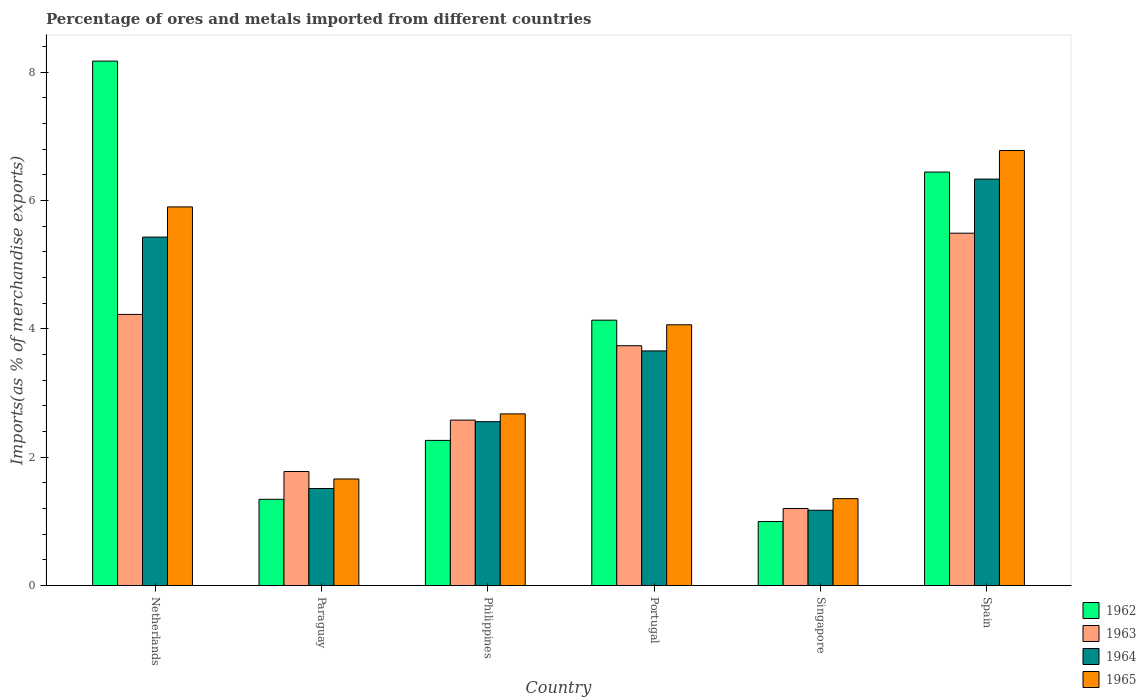How many groups of bars are there?
Your answer should be very brief. 6. How many bars are there on the 1st tick from the left?
Your answer should be compact. 4. What is the label of the 2nd group of bars from the left?
Keep it short and to the point. Paraguay. In how many cases, is the number of bars for a given country not equal to the number of legend labels?
Your answer should be very brief. 0. What is the percentage of imports to different countries in 1964 in Netherlands?
Ensure brevity in your answer.  5.43. Across all countries, what is the maximum percentage of imports to different countries in 1964?
Provide a succinct answer. 6.33. Across all countries, what is the minimum percentage of imports to different countries in 1965?
Ensure brevity in your answer.  1.35. In which country was the percentage of imports to different countries in 1964 minimum?
Your answer should be very brief. Singapore. What is the total percentage of imports to different countries in 1964 in the graph?
Keep it short and to the point. 20.66. What is the difference between the percentage of imports to different countries in 1964 in Netherlands and that in Philippines?
Give a very brief answer. 2.88. What is the difference between the percentage of imports to different countries in 1964 in Paraguay and the percentage of imports to different countries in 1965 in Singapore?
Make the answer very short. 0.16. What is the average percentage of imports to different countries in 1962 per country?
Provide a short and direct response. 3.89. What is the difference between the percentage of imports to different countries of/in 1963 and percentage of imports to different countries of/in 1965 in Spain?
Your answer should be very brief. -1.29. In how many countries, is the percentage of imports to different countries in 1963 greater than 2 %?
Offer a terse response. 4. What is the ratio of the percentage of imports to different countries in 1962 in Singapore to that in Spain?
Offer a terse response. 0.15. What is the difference between the highest and the second highest percentage of imports to different countries in 1965?
Ensure brevity in your answer.  -1.84. What is the difference between the highest and the lowest percentage of imports to different countries in 1965?
Keep it short and to the point. 5.42. Is the sum of the percentage of imports to different countries in 1964 in Netherlands and Spain greater than the maximum percentage of imports to different countries in 1962 across all countries?
Your answer should be compact. Yes. Is it the case that in every country, the sum of the percentage of imports to different countries in 1962 and percentage of imports to different countries in 1963 is greater than the sum of percentage of imports to different countries in 1965 and percentage of imports to different countries in 1964?
Your response must be concise. No. What does the 4th bar from the left in Philippines represents?
Provide a short and direct response. 1965. What does the 4th bar from the right in Singapore represents?
Give a very brief answer. 1962. Is it the case that in every country, the sum of the percentage of imports to different countries in 1964 and percentage of imports to different countries in 1962 is greater than the percentage of imports to different countries in 1965?
Make the answer very short. Yes. Are all the bars in the graph horizontal?
Your response must be concise. No. What is the difference between two consecutive major ticks on the Y-axis?
Your response must be concise. 2. Does the graph contain any zero values?
Give a very brief answer. No. Does the graph contain grids?
Ensure brevity in your answer.  No. How many legend labels are there?
Your answer should be very brief. 4. What is the title of the graph?
Give a very brief answer. Percentage of ores and metals imported from different countries. What is the label or title of the X-axis?
Provide a succinct answer. Country. What is the label or title of the Y-axis?
Your answer should be very brief. Imports(as % of merchandise exports). What is the Imports(as % of merchandise exports) of 1962 in Netherlands?
Give a very brief answer. 8.17. What is the Imports(as % of merchandise exports) in 1963 in Netherlands?
Give a very brief answer. 4.22. What is the Imports(as % of merchandise exports) of 1964 in Netherlands?
Provide a succinct answer. 5.43. What is the Imports(as % of merchandise exports) of 1965 in Netherlands?
Make the answer very short. 5.9. What is the Imports(as % of merchandise exports) in 1962 in Paraguay?
Offer a very short reply. 1.34. What is the Imports(as % of merchandise exports) of 1963 in Paraguay?
Ensure brevity in your answer.  1.78. What is the Imports(as % of merchandise exports) of 1964 in Paraguay?
Provide a short and direct response. 1.51. What is the Imports(as % of merchandise exports) of 1965 in Paraguay?
Provide a short and direct response. 1.66. What is the Imports(as % of merchandise exports) in 1962 in Philippines?
Your response must be concise. 2.26. What is the Imports(as % of merchandise exports) of 1963 in Philippines?
Offer a terse response. 2.58. What is the Imports(as % of merchandise exports) in 1964 in Philippines?
Provide a short and direct response. 2.55. What is the Imports(as % of merchandise exports) of 1965 in Philippines?
Keep it short and to the point. 2.67. What is the Imports(as % of merchandise exports) in 1962 in Portugal?
Make the answer very short. 4.13. What is the Imports(as % of merchandise exports) of 1963 in Portugal?
Offer a very short reply. 3.74. What is the Imports(as % of merchandise exports) in 1964 in Portugal?
Your answer should be very brief. 3.66. What is the Imports(as % of merchandise exports) in 1965 in Portugal?
Provide a short and direct response. 4.06. What is the Imports(as % of merchandise exports) of 1962 in Singapore?
Offer a terse response. 1. What is the Imports(as % of merchandise exports) in 1963 in Singapore?
Ensure brevity in your answer.  1.2. What is the Imports(as % of merchandise exports) of 1964 in Singapore?
Provide a short and direct response. 1.17. What is the Imports(as % of merchandise exports) of 1965 in Singapore?
Your answer should be very brief. 1.35. What is the Imports(as % of merchandise exports) of 1962 in Spain?
Offer a very short reply. 6.44. What is the Imports(as % of merchandise exports) in 1963 in Spain?
Your answer should be very brief. 5.49. What is the Imports(as % of merchandise exports) of 1964 in Spain?
Your answer should be very brief. 6.33. What is the Imports(as % of merchandise exports) in 1965 in Spain?
Keep it short and to the point. 6.78. Across all countries, what is the maximum Imports(as % of merchandise exports) in 1962?
Give a very brief answer. 8.17. Across all countries, what is the maximum Imports(as % of merchandise exports) in 1963?
Give a very brief answer. 5.49. Across all countries, what is the maximum Imports(as % of merchandise exports) of 1964?
Keep it short and to the point. 6.33. Across all countries, what is the maximum Imports(as % of merchandise exports) of 1965?
Your response must be concise. 6.78. Across all countries, what is the minimum Imports(as % of merchandise exports) of 1962?
Provide a short and direct response. 1. Across all countries, what is the minimum Imports(as % of merchandise exports) of 1963?
Provide a short and direct response. 1.2. Across all countries, what is the minimum Imports(as % of merchandise exports) of 1964?
Offer a terse response. 1.17. Across all countries, what is the minimum Imports(as % of merchandise exports) in 1965?
Provide a short and direct response. 1.35. What is the total Imports(as % of merchandise exports) in 1962 in the graph?
Provide a short and direct response. 23.35. What is the total Imports(as % of merchandise exports) of 1963 in the graph?
Provide a short and direct response. 19.01. What is the total Imports(as % of merchandise exports) of 1964 in the graph?
Keep it short and to the point. 20.66. What is the total Imports(as % of merchandise exports) of 1965 in the graph?
Offer a terse response. 22.43. What is the difference between the Imports(as % of merchandise exports) of 1962 in Netherlands and that in Paraguay?
Your answer should be compact. 6.83. What is the difference between the Imports(as % of merchandise exports) in 1963 in Netherlands and that in Paraguay?
Offer a terse response. 2.45. What is the difference between the Imports(as % of merchandise exports) of 1964 in Netherlands and that in Paraguay?
Ensure brevity in your answer.  3.92. What is the difference between the Imports(as % of merchandise exports) in 1965 in Netherlands and that in Paraguay?
Ensure brevity in your answer.  4.24. What is the difference between the Imports(as % of merchandise exports) of 1962 in Netherlands and that in Philippines?
Offer a very short reply. 5.91. What is the difference between the Imports(as % of merchandise exports) of 1963 in Netherlands and that in Philippines?
Offer a very short reply. 1.65. What is the difference between the Imports(as % of merchandise exports) in 1964 in Netherlands and that in Philippines?
Offer a terse response. 2.88. What is the difference between the Imports(as % of merchandise exports) of 1965 in Netherlands and that in Philippines?
Offer a very short reply. 3.22. What is the difference between the Imports(as % of merchandise exports) in 1962 in Netherlands and that in Portugal?
Make the answer very short. 4.04. What is the difference between the Imports(as % of merchandise exports) in 1963 in Netherlands and that in Portugal?
Provide a short and direct response. 0.49. What is the difference between the Imports(as % of merchandise exports) of 1964 in Netherlands and that in Portugal?
Keep it short and to the point. 1.77. What is the difference between the Imports(as % of merchandise exports) in 1965 in Netherlands and that in Portugal?
Keep it short and to the point. 1.84. What is the difference between the Imports(as % of merchandise exports) in 1962 in Netherlands and that in Singapore?
Ensure brevity in your answer.  7.17. What is the difference between the Imports(as % of merchandise exports) of 1963 in Netherlands and that in Singapore?
Provide a short and direct response. 3.02. What is the difference between the Imports(as % of merchandise exports) of 1964 in Netherlands and that in Singapore?
Offer a very short reply. 4.26. What is the difference between the Imports(as % of merchandise exports) in 1965 in Netherlands and that in Singapore?
Give a very brief answer. 4.55. What is the difference between the Imports(as % of merchandise exports) in 1962 in Netherlands and that in Spain?
Your response must be concise. 1.73. What is the difference between the Imports(as % of merchandise exports) of 1963 in Netherlands and that in Spain?
Offer a terse response. -1.27. What is the difference between the Imports(as % of merchandise exports) of 1964 in Netherlands and that in Spain?
Your response must be concise. -0.9. What is the difference between the Imports(as % of merchandise exports) of 1965 in Netherlands and that in Spain?
Your answer should be compact. -0.88. What is the difference between the Imports(as % of merchandise exports) of 1962 in Paraguay and that in Philippines?
Provide a short and direct response. -0.92. What is the difference between the Imports(as % of merchandise exports) of 1963 in Paraguay and that in Philippines?
Ensure brevity in your answer.  -0.8. What is the difference between the Imports(as % of merchandise exports) of 1964 in Paraguay and that in Philippines?
Your answer should be compact. -1.04. What is the difference between the Imports(as % of merchandise exports) in 1965 in Paraguay and that in Philippines?
Ensure brevity in your answer.  -1.01. What is the difference between the Imports(as % of merchandise exports) in 1962 in Paraguay and that in Portugal?
Keep it short and to the point. -2.79. What is the difference between the Imports(as % of merchandise exports) of 1963 in Paraguay and that in Portugal?
Give a very brief answer. -1.96. What is the difference between the Imports(as % of merchandise exports) of 1964 in Paraguay and that in Portugal?
Your answer should be very brief. -2.14. What is the difference between the Imports(as % of merchandise exports) of 1965 in Paraguay and that in Portugal?
Provide a short and direct response. -2.4. What is the difference between the Imports(as % of merchandise exports) of 1962 in Paraguay and that in Singapore?
Your response must be concise. 0.35. What is the difference between the Imports(as % of merchandise exports) of 1963 in Paraguay and that in Singapore?
Offer a terse response. 0.58. What is the difference between the Imports(as % of merchandise exports) in 1964 in Paraguay and that in Singapore?
Provide a succinct answer. 0.34. What is the difference between the Imports(as % of merchandise exports) in 1965 in Paraguay and that in Singapore?
Provide a short and direct response. 0.31. What is the difference between the Imports(as % of merchandise exports) of 1962 in Paraguay and that in Spain?
Keep it short and to the point. -5.1. What is the difference between the Imports(as % of merchandise exports) of 1963 in Paraguay and that in Spain?
Offer a terse response. -3.71. What is the difference between the Imports(as % of merchandise exports) in 1964 in Paraguay and that in Spain?
Your answer should be compact. -4.82. What is the difference between the Imports(as % of merchandise exports) of 1965 in Paraguay and that in Spain?
Give a very brief answer. -5.12. What is the difference between the Imports(as % of merchandise exports) of 1962 in Philippines and that in Portugal?
Give a very brief answer. -1.87. What is the difference between the Imports(as % of merchandise exports) in 1963 in Philippines and that in Portugal?
Offer a very short reply. -1.16. What is the difference between the Imports(as % of merchandise exports) of 1964 in Philippines and that in Portugal?
Offer a terse response. -1.1. What is the difference between the Imports(as % of merchandise exports) of 1965 in Philippines and that in Portugal?
Your answer should be compact. -1.39. What is the difference between the Imports(as % of merchandise exports) of 1962 in Philippines and that in Singapore?
Keep it short and to the point. 1.26. What is the difference between the Imports(as % of merchandise exports) in 1963 in Philippines and that in Singapore?
Your answer should be compact. 1.38. What is the difference between the Imports(as % of merchandise exports) in 1964 in Philippines and that in Singapore?
Your response must be concise. 1.38. What is the difference between the Imports(as % of merchandise exports) in 1965 in Philippines and that in Singapore?
Offer a terse response. 1.32. What is the difference between the Imports(as % of merchandise exports) of 1962 in Philippines and that in Spain?
Offer a terse response. -4.18. What is the difference between the Imports(as % of merchandise exports) of 1963 in Philippines and that in Spain?
Offer a very short reply. -2.91. What is the difference between the Imports(as % of merchandise exports) of 1964 in Philippines and that in Spain?
Offer a terse response. -3.78. What is the difference between the Imports(as % of merchandise exports) in 1965 in Philippines and that in Spain?
Ensure brevity in your answer.  -4.1. What is the difference between the Imports(as % of merchandise exports) in 1962 in Portugal and that in Singapore?
Your answer should be very brief. 3.14. What is the difference between the Imports(as % of merchandise exports) in 1963 in Portugal and that in Singapore?
Provide a succinct answer. 2.54. What is the difference between the Imports(as % of merchandise exports) of 1964 in Portugal and that in Singapore?
Ensure brevity in your answer.  2.48. What is the difference between the Imports(as % of merchandise exports) in 1965 in Portugal and that in Singapore?
Offer a very short reply. 2.71. What is the difference between the Imports(as % of merchandise exports) in 1962 in Portugal and that in Spain?
Your answer should be compact. -2.31. What is the difference between the Imports(as % of merchandise exports) in 1963 in Portugal and that in Spain?
Your answer should be compact. -1.75. What is the difference between the Imports(as % of merchandise exports) in 1964 in Portugal and that in Spain?
Your answer should be very brief. -2.68. What is the difference between the Imports(as % of merchandise exports) of 1965 in Portugal and that in Spain?
Provide a short and direct response. -2.72. What is the difference between the Imports(as % of merchandise exports) in 1962 in Singapore and that in Spain?
Your answer should be very brief. -5.45. What is the difference between the Imports(as % of merchandise exports) of 1963 in Singapore and that in Spain?
Give a very brief answer. -4.29. What is the difference between the Imports(as % of merchandise exports) of 1964 in Singapore and that in Spain?
Provide a short and direct response. -5.16. What is the difference between the Imports(as % of merchandise exports) of 1965 in Singapore and that in Spain?
Your answer should be compact. -5.42. What is the difference between the Imports(as % of merchandise exports) in 1962 in Netherlands and the Imports(as % of merchandise exports) in 1963 in Paraguay?
Offer a very short reply. 6.39. What is the difference between the Imports(as % of merchandise exports) of 1962 in Netherlands and the Imports(as % of merchandise exports) of 1964 in Paraguay?
Offer a terse response. 6.66. What is the difference between the Imports(as % of merchandise exports) in 1962 in Netherlands and the Imports(as % of merchandise exports) in 1965 in Paraguay?
Your answer should be compact. 6.51. What is the difference between the Imports(as % of merchandise exports) of 1963 in Netherlands and the Imports(as % of merchandise exports) of 1964 in Paraguay?
Offer a terse response. 2.71. What is the difference between the Imports(as % of merchandise exports) in 1963 in Netherlands and the Imports(as % of merchandise exports) in 1965 in Paraguay?
Provide a short and direct response. 2.56. What is the difference between the Imports(as % of merchandise exports) in 1964 in Netherlands and the Imports(as % of merchandise exports) in 1965 in Paraguay?
Offer a terse response. 3.77. What is the difference between the Imports(as % of merchandise exports) of 1962 in Netherlands and the Imports(as % of merchandise exports) of 1963 in Philippines?
Make the answer very short. 5.59. What is the difference between the Imports(as % of merchandise exports) in 1962 in Netherlands and the Imports(as % of merchandise exports) in 1964 in Philippines?
Your response must be concise. 5.62. What is the difference between the Imports(as % of merchandise exports) in 1962 in Netherlands and the Imports(as % of merchandise exports) in 1965 in Philippines?
Your response must be concise. 5.5. What is the difference between the Imports(as % of merchandise exports) of 1963 in Netherlands and the Imports(as % of merchandise exports) of 1964 in Philippines?
Your response must be concise. 1.67. What is the difference between the Imports(as % of merchandise exports) in 1963 in Netherlands and the Imports(as % of merchandise exports) in 1965 in Philippines?
Your response must be concise. 1.55. What is the difference between the Imports(as % of merchandise exports) in 1964 in Netherlands and the Imports(as % of merchandise exports) in 1965 in Philippines?
Your answer should be very brief. 2.75. What is the difference between the Imports(as % of merchandise exports) of 1962 in Netherlands and the Imports(as % of merchandise exports) of 1963 in Portugal?
Keep it short and to the point. 4.43. What is the difference between the Imports(as % of merchandise exports) in 1962 in Netherlands and the Imports(as % of merchandise exports) in 1964 in Portugal?
Provide a short and direct response. 4.51. What is the difference between the Imports(as % of merchandise exports) of 1962 in Netherlands and the Imports(as % of merchandise exports) of 1965 in Portugal?
Your answer should be compact. 4.11. What is the difference between the Imports(as % of merchandise exports) of 1963 in Netherlands and the Imports(as % of merchandise exports) of 1964 in Portugal?
Provide a succinct answer. 0.57. What is the difference between the Imports(as % of merchandise exports) in 1963 in Netherlands and the Imports(as % of merchandise exports) in 1965 in Portugal?
Your answer should be very brief. 0.16. What is the difference between the Imports(as % of merchandise exports) in 1964 in Netherlands and the Imports(as % of merchandise exports) in 1965 in Portugal?
Provide a succinct answer. 1.37. What is the difference between the Imports(as % of merchandise exports) of 1962 in Netherlands and the Imports(as % of merchandise exports) of 1963 in Singapore?
Provide a succinct answer. 6.97. What is the difference between the Imports(as % of merchandise exports) in 1962 in Netherlands and the Imports(as % of merchandise exports) in 1964 in Singapore?
Offer a very short reply. 7. What is the difference between the Imports(as % of merchandise exports) in 1962 in Netherlands and the Imports(as % of merchandise exports) in 1965 in Singapore?
Make the answer very short. 6.82. What is the difference between the Imports(as % of merchandise exports) of 1963 in Netherlands and the Imports(as % of merchandise exports) of 1964 in Singapore?
Make the answer very short. 3.05. What is the difference between the Imports(as % of merchandise exports) in 1963 in Netherlands and the Imports(as % of merchandise exports) in 1965 in Singapore?
Keep it short and to the point. 2.87. What is the difference between the Imports(as % of merchandise exports) in 1964 in Netherlands and the Imports(as % of merchandise exports) in 1965 in Singapore?
Make the answer very short. 4.07. What is the difference between the Imports(as % of merchandise exports) of 1962 in Netherlands and the Imports(as % of merchandise exports) of 1963 in Spain?
Your answer should be very brief. 2.68. What is the difference between the Imports(as % of merchandise exports) of 1962 in Netherlands and the Imports(as % of merchandise exports) of 1964 in Spain?
Give a very brief answer. 1.84. What is the difference between the Imports(as % of merchandise exports) in 1962 in Netherlands and the Imports(as % of merchandise exports) in 1965 in Spain?
Provide a succinct answer. 1.39. What is the difference between the Imports(as % of merchandise exports) of 1963 in Netherlands and the Imports(as % of merchandise exports) of 1964 in Spain?
Offer a very short reply. -2.11. What is the difference between the Imports(as % of merchandise exports) of 1963 in Netherlands and the Imports(as % of merchandise exports) of 1965 in Spain?
Your answer should be very brief. -2.55. What is the difference between the Imports(as % of merchandise exports) of 1964 in Netherlands and the Imports(as % of merchandise exports) of 1965 in Spain?
Provide a short and direct response. -1.35. What is the difference between the Imports(as % of merchandise exports) of 1962 in Paraguay and the Imports(as % of merchandise exports) of 1963 in Philippines?
Make the answer very short. -1.23. What is the difference between the Imports(as % of merchandise exports) of 1962 in Paraguay and the Imports(as % of merchandise exports) of 1964 in Philippines?
Your answer should be compact. -1.21. What is the difference between the Imports(as % of merchandise exports) in 1962 in Paraguay and the Imports(as % of merchandise exports) in 1965 in Philippines?
Offer a terse response. -1.33. What is the difference between the Imports(as % of merchandise exports) in 1963 in Paraguay and the Imports(as % of merchandise exports) in 1964 in Philippines?
Ensure brevity in your answer.  -0.78. What is the difference between the Imports(as % of merchandise exports) in 1963 in Paraguay and the Imports(as % of merchandise exports) in 1965 in Philippines?
Your response must be concise. -0.9. What is the difference between the Imports(as % of merchandise exports) of 1964 in Paraguay and the Imports(as % of merchandise exports) of 1965 in Philippines?
Offer a very short reply. -1.16. What is the difference between the Imports(as % of merchandise exports) of 1962 in Paraguay and the Imports(as % of merchandise exports) of 1963 in Portugal?
Offer a terse response. -2.39. What is the difference between the Imports(as % of merchandise exports) of 1962 in Paraguay and the Imports(as % of merchandise exports) of 1964 in Portugal?
Your answer should be very brief. -2.31. What is the difference between the Imports(as % of merchandise exports) of 1962 in Paraguay and the Imports(as % of merchandise exports) of 1965 in Portugal?
Provide a short and direct response. -2.72. What is the difference between the Imports(as % of merchandise exports) in 1963 in Paraguay and the Imports(as % of merchandise exports) in 1964 in Portugal?
Make the answer very short. -1.88. What is the difference between the Imports(as % of merchandise exports) in 1963 in Paraguay and the Imports(as % of merchandise exports) in 1965 in Portugal?
Your answer should be compact. -2.29. What is the difference between the Imports(as % of merchandise exports) in 1964 in Paraguay and the Imports(as % of merchandise exports) in 1965 in Portugal?
Offer a terse response. -2.55. What is the difference between the Imports(as % of merchandise exports) in 1962 in Paraguay and the Imports(as % of merchandise exports) in 1963 in Singapore?
Provide a short and direct response. 0.14. What is the difference between the Imports(as % of merchandise exports) of 1962 in Paraguay and the Imports(as % of merchandise exports) of 1964 in Singapore?
Provide a succinct answer. 0.17. What is the difference between the Imports(as % of merchandise exports) of 1962 in Paraguay and the Imports(as % of merchandise exports) of 1965 in Singapore?
Ensure brevity in your answer.  -0.01. What is the difference between the Imports(as % of merchandise exports) of 1963 in Paraguay and the Imports(as % of merchandise exports) of 1964 in Singapore?
Offer a terse response. 0.6. What is the difference between the Imports(as % of merchandise exports) of 1963 in Paraguay and the Imports(as % of merchandise exports) of 1965 in Singapore?
Your answer should be compact. 0.42. What is the difference between the Imports(as % of merchandise exports) in 1964 in Paraguay and the Imports(as % of merchandise exports) in 1965 in Singapore?
Your response must be concise. 0.16. What is the difference between the Imports(as % of merchandise exports) of 1962 in Paraguay and the Imports(as % of merchandise exports) of 1963 in Spain?
Offer a very short reply. -4.15. What is the difference between the Imports(as % of merchandise exports) of 1962 in Paraguay and the Imports(as % of merchandise exports) of 1964 in Spain?
Ensure brevity in your answer.  -4.99. What is the difference between the Imports(as % of merchandise exports) of 1962 in Paraguay and the Imports(as % of merchandise exports) of 1965 in Spain?
Your answer should be very brief. -5.43. What is the difference between the Imports(as % of merchandise exports) of 1963 in Paraguay and the Imports(as % of merchandise exports) of 1964 in Spain?
Your response must be concise. -4.56. What is the difference between the Imports(as % of merchandise exports) of 1963 in Paraguay and the Imports(as % of merchandise exports) of 1965 in Spain?
Your answer should be compact. -5. What is the difference between the Imports(as % of merchandise exports) of 1964 in Paraguay and the Imports(as % of merchandise exports) of 1965 in Spain?
Make the answer very short. -5.27. What is the difference between the Imports(as % of merchandise exports) in 1962 in Philippines and the Imports(as % of merchandise exports) in 1963 in Portugal?
Provide a succinct answer. -1.47. What is the difference between the Imports(as % of merchandise exports) in 1962 in Philippines and the Imports(as % of merchandise exports) in 1964 in Portugal?
Offer a very short reply. -1.39. What is the difference between the Imports(as % of merchandise exports) of 1962 in Philippines and the Imports(as % of merchandise exports) of 1965 in Portugal?
Provide a short and direct response. -1.8. What is the difference between the Imports(as % of merchandise exports) in 1963 in Philippines and the Imports(as % of merchandise exports) in 1964 in Portugal?
Your answer should be very brief. -1.08. What is the difference between the Imports(as % of merchandise exports) of 1963 in Philippines and the Imports(as % of merchandise exports) of 1965 in Portugal?
Offer a very short reply. -1.48. What is the difference between the Imports(as % of merchandise exports) in 1964 in Philippines and the Imports(as % of merchandise exports) in 1965 in Portugal?
Ensure brevity in your answer.  -1.51. What is the difference between the Imports(as % of merchandise exports) in 1962 in Philippines and the Imports(as % of merchandise exports) in 1963 in Singapore?
Your answer should be compact. 1.06. What is the difference between the Imports(as % of merchandise exports) in 1962 in Philippines and the Imports(as % of merchandise exports) in 1964 in Singapore?
Keep it short and to the point. 1.09. What is the difference between the Imports(as % of merchandise exports) of 1962 in Philippines and the Imports(as % of merchandise exports) of 1965 in Singapore?
Offer a terse response. 0.91. What is the difference between the Imports(as % of merchandise exports) of 1963 in Philippines and the Imports(as % of merchandise exports) of 1964 in Singapore?
Your response must be concise. 1.4. What is the difference between the Imports(as % of merchandise exports) in 1963 in Philippines and the Imports(as % of merchandise exports) in 1965 in Singapore?
Make the answer very short. 1.22. What is the difference between the Imports(as % of merchandise exports) of 1964 in Philippines and the Imports(as % of merchandise exports) of 1965 in Singapore?
Offer a very short reply. 1.2. What is the difference between the Imports(as % of merchandise exports) in 1962 in Philippines and the Imports(as % of merchandise exports) in 1963 in Spain?
Your response must be concise. -3.23. What is the difference between the Imports(as % of merchandise exports) of 1962 in Philippines and the Imports(as % of merchandise exports) of 1964 in Spain?
Provide a short and direct response. -4.07. What is the difference between the Imports(as % of merchandise exports) of 1962 in Philippines and the Imports(as % of merchandise exports) of 1965 in Spain?
Offer a very short reply. -4.52. What is the difference between the Imports(as % of merchandise exports) of 1963 in Philippines and the Imports(as % of merchandise exports) of 1964 in Spain?
Provide a short and direct response. -3.75. What is the difference between the Imports(as % of merchandise exports) of 1963 in Philippines and the Imports(as % of merchandise exports) of 1965 in Spain?
Provide a succinct answer. -4.2. What is the difference between the Imports(as % of merchandise exports) of 1964 in Philippines and the Imports(as % of merchandise exports) of 1965 in Spain?
Keep it short and to the point. -4.22. What is the difference between the Imports(as % of merchandise exports) in 1962 in Portugal and the Imports(as % of merchandise exports) in 1963 in Singapore?
Provide a succinct answer. 2.93. What is the difference between the Imports(as % of merchandise exports) in 1962 in Portugal and the Imports(as % of merchandise exports) in 1964 in Singapore?
Keep it short and to the point. 2.96. What is the difference between the Imports(as % of merchandise exports) in 1962 in Portugal and the Imports(as % of merchandise exports) in 1965 in Singapore?
Your answer should be very brief. 2.78. What is the difference between the Imports(as % of merchandise exports) of 1963 in Portugal and the Imports(as % of merchandise exports) of 1964 in Singapore?
Your response must be concise. 2.56. What is the difference between the Imports(as % of merchandise exports) of 1963 in Portugal and the Imports(as % of merchandise exports) of 1965 in Singapore?
Provide a short and direct response. 2.38. What is the difference between the Imports(as % of merchandise exports) of 1964 in Portugal and the Imports(as % of merchandise exports) of 1965 in Singapore?
Make the answer very short. 2.3. What is the difference between the Imports(as % of merchandise exports) of 1962 in Portugal and the Imports(as % of merchandise exports) of 1963 in Spain?
Make the answer very short. -1.36. What is the difference between the Imports(as % of merchandise exports) in 1962 in Portugal and the Imports(as % of merchandise exports) in 1964 in Spain?
Ensure brevity in your answer.  -2.2. What is the difference between the Imports(as % of merchandise exports) of 1962 in Portugal and the Imports(as % of merchandise exports) of 1965 in Spain?
Offer a very short reply. -2.64. What is the difference between the Imports(as % of merchandise exports) of 1963 in Portugal and the Imports(as % of merchandise exports) of 1964 in Spain?
Make the answer very short. -2.6. What is the difference between the Imports(as % of merchandise exports) of 1963 in Portugal and the Imports(as % of merchandise exports) of 1965 in Spain?
Give a very brief answer. -3.04. What is the difference between the Imports(as % of merchandise exports) in 1964 in Portugal and the Imports(as % of merchandise exports) in 1965 in Spain?
Your answer should be compact. -3.12. What is the difference between the Imports(as % of merchandise exports) in 1962 in Singapore and the Imports(as % of merchandise exports) in 1963 in Spain?
Give a very brief answer. -4.49. What is the difference between the Imports(as % of merchandise exports) of 1962 in Singapore and the Imports(as % of merchandise exports) of 1964 in Spain?
Ensure brevity in your answer.  -5.34. What is the difference between the Imports(as % of merchandise exports) in 1962 in Singapore and the Imports(as % of merchandise exports) in 1965 in Spain?
Your answer should be compact. -5.78. What is the difference between the Imports(as % of merchandise exports) in 1963 in Singapore and the Imports(as % of merchandise exports) in 1964 in Spain?
Your answer should be very brief. -5.13. What is the difference between the Imports(as % of merchandise exports) in 1963 in Singapore and the Imports(as % of merchandise exports) in 1965 in Spain?
Your answer should be compact. -5.58. What is the difference between the Imports(as % of merchandise exports) of 1964 in Singapore and the Imports(as % of merchandise exports) of 1965 in Spain?
Offer a terse response. -5.61. What is the average Imports(as % of merchandise exports) in 1962 per country?
Provide a short and direct response. 3.89. What is the average Imports(as % of merchandise exports) of 1963 per country?
Your answer should be very brief. 3.17. What is the average Imports(as % of merchandise exports) in 1964 per country?
Make the answer very short. 3.44. What is the average Imports(as % of merchandise exports) in 1965 per country?
Your answer should be very brief. 3.74. What is the difference between the Imports(as % of merchandise exports) of 1962 and Imports(as % of merchandise exports) of 1963 in Netherlands?
Your response must be concise. 3.95. What is the difference between the Imports(as % of merchandise exports) of 1962 and Imports(as % of merchandise exports) of 1964 in Netherlands?
Provide a succinct answer. 2.74. What is the difference between the Imports(as % of merchandise exports) in 1962 and Imports(as % of merchandise exports) in 1965 in Netherlands?
Offer a very short reply. 2.27. What is the difference between the Imports(as % of merchandise exports) in 1963 and Imports(as % of merchandise exports) in 1964 in Netherlands?
Your answer should be very brief. -1.2. What is the difference between the Imports(as % of merchandise exports) in 1963 and Imports(as % of merchandise exports) in 1965 in Netherlands?
Keep it short and to the point. -1.67. What is the difference between the Imports(as % of merchandise exports) in 1964 and Imports(as % of merchandise exports) in 1965 in Netherlands?
Your response must be concise. -0.47. What is the difference between the Imports(as % of merchandise exports) in 1962 and Imports(as % of merchandise exports) in 1963 in Paraguay?
Keep it short and to the point. -0.43. What is the difference between the Imports(as % of merchandise exports) of 1962 and Imports(as % of merchandise exports) of 1964 in Paraguay?
Provide a short and direct response. -0.17. What is the difference between the Imports(as % of merchandise exports) in 1962 and Imports(as % of merchandise exports) in 1965 in Paraguay?
Provide a succinct answer. -0.32. What is the difference between the Imports(as % of merchandise exports) of 1963 and Imports(as % of merchandise exports) of 1964 in Paraguay?
Your answer should be compact. 0.26. What is the difference between the Imports(as % of merchandise exports) of 1963 and Imports(as % of merchandise exports) of 1965 in Paraguay?
Ensure brevity in your answer.  0.12. What is the difference between the Imports(as % of merchandise exports) of 1964 and Imports(as % of merchandise exports) of 1965 in Paraguay?
Ensure brevity in your answer.  -0.15. What is the difference between the Imports(as % of merchandise exports) of 1962 and Imports(as % of merchandise exports) of 1963 in Philippines?
Offer a terse response. -0.32. What is the difference between the Imports(as % of merchandise exports) of 1962 and Imports(as % of merchandise exports) of 1964 in Philippines?
Ensure brevity in your answer.  -0.29. What is the difference between the Imports(as % of merchandise exports) in 1962 and Imports(as % of merchandise exports) in 1965 in Philippines?
Ensure brevity in your answer.  -0.41. What is the difference between the Imports(as % of merchandise exports) in 1963 and Imports(as % of merchandise exports) in 1964 in Philippines?
Give a very brief answer. 0.02. What is the difference between the Imports(as % of merchandise exports) in 1963 and Imports(as % of merchandise exports) in 1965 in Philippines?
Ensure brevity in your answer.  -0.1. What is the difference between the Imports(as % of merchandise exports) of 1964 and Imports(as % of merchandise exports) of 1965 in Philippines?
Your answer should be very brief. -0.12. What is the difference between the Imports(as % of merchandise exports) of 1962 and Imports(as % of merchandise exports) of 1963 in Portugal?
Your answer should be compact. 0.4. What is the difference between the Imports(as % of merchandise exports) of 1962 and Imports(as % of merchandise exports) of 1964 in Portugal?
Keep it short and to the point. 0.48. What is the difference between the Imports(as % of merchandise exports) in 1962 and Imports(as % of merchandise exports) in 1965 in Portugal?
Offer a terse response. 0.07. What is the difference between the Imports(as % of merchandise exports) in 1963 and Imports(as % of merchandise exports) in 1964 in Portugal?
Keep it short and to the point. 0.08. What is the difference between the Imports(as % of merchandise exports) in 1963 and Imports(as % of merchandise exports) in 1965 in Portugal?
Provide a short and direct response. -0.33. What is the difference between the Imports(as % of merchandise exports) of 1964 and Imports(as % of merchandise exports) of 1965 in Portugal?
Make the answer very short. -0.41. What is the difference between the Imports(as % of merchandise exports) in 1962 and Imports(as % of merchandise exports) in 1963 in Singapore?
Provide a succinct answer. -0.2. What is the difference between the Imports(as % of merchandise exports) of 1962 and Imports(as % of merchandise exports) of 1964 in Singapore?
Make the answer very short. -0.18. What is the difference between the Imports(as % of merchandise exports) in 1962 and Imports(as % of merchandise exports) in 1965 in Singapore?
Your answer should be very brief. -0.36. What is the difference between the Imports(as % of merchandise exports) in 1963 and Imports(as % of merchandise exports) in 1964 in Singapore?
Keep it short and to the point. 0.03. What is the difference between the Imports(as % of merchandise exports) of 1963 and Imports(as % of merchandise exports) of 1965 in Singapore?
Make the answer very short. -0.15. What is the difference between the Imports(as % of merchandise exports) in 1964 and Imports(as % of merchandise exports) in 1965 in Singapore?
Offer a very short reply. -0.18. What is the difference between the Imports(as % of merchandise exports) in 1962 and Imports(as % of merchandise exports) in 1964 in Spain?
Make the answer very short. 0.11. What is the difference between the Imports(as % of merchandise exports) in 1962 and Imports(as % of merchandise exports) in 1965 in Spain?
Offer a very short reply. -0.34. What is the difference between the Imports(as % of merchandise exports) in 1963 and Imports(as % of merchandise exports) in 1964 in Spain?
Your answer should be compact. -0.84. What is the difference between the Imports(as % of merchandise exports) in 1963 and Imports(as % of merchandise exports) in 1965 in Spain?
Your response must be concise. -1.29. What is the difference between the Imports(as % of merchandise exports) of 1964 and Imports(as % of merchandise exports) of 1965 in Spain?
Keep it short and to the point. -0.45. What is the ratio of the Imports(as % of merchandise exports) of 1962 in Netherlands to that in Paraguay?
Provide a short and direct response. 6.08. What is the ratio of the Imports(as % of merchandise exports) of 1963 in Netherlands to that in Paraguay?
Provide a succinct answer. 2.38. What is the ratio of the Imports(as % of merchandise exports) in 1964 in Netherlands to that in Paraguay?
Offer a terse response. 3.59. What is the ratio of the Imports(as % of merchandise exports) in 1965 in Netherlands to that in Paraguay?
Provide a succinct answer. 3.55. What is the ratio of the Imports(as % of merchandise exports) of 1962 in Netherlands to that in Philippines?
Ensure brevity in your answer.  3.61. What is the ratio of the Imports(as % of merchandise exports) in 1963 in Netherlands to that in Philippines?
Keep it short and to the point. 1.64. What is the ratio of the Imports(as % of merchandise exports) in 1964 in Netherlands to that in Philippines?
Offer a terse response. 2.13. What is the ratio of the Imports(as % of merchandise exports) of 1965 in Netherlands to that in Philippines?
Keep it short and to the point. 2.21. What is the ratio of the Imports(as % of merchandise exports) of 1962 in Netherlands to that in Portugal?
Your answer should be very brief. 1.98. What is the ratio of the Imports(as % of merchandise exports) of 1963 in Netherlands to that in Portugal?
Ensure brevity in your answer.  1.13. What is the ratio of the Imports(as % of merchandise exports) of 1964 in Netherlands to that in Portugal?
Your response must be concise. 1.49. What is the ratio of the Imports(as % of merchandise exports) of 1965 in Netherlands to that in Portugal?
Offer a very short reply. 1.45. What is the ratio of the Imports(as % of merchandise exports) in 1962 in Netherlands to that in Singapore?
Your answer should be very brief. 8.19. What is the ratio of the Imports(as % of merchandise exports) in 1963 in Netherlands to that in Singapore?
Provide a succinct answer. 3.52. What is the ratio of the Imports(as % of merchandise exports) in 1964 in Netherlands to that in Singapore?
Make the answer very short. 4.63. What is the ratio of the Imports(as % of merchandise exports) in 1965 in Netherlands to that in Singapore?
Your response must be concise. 4.36. What is the ratio of the Imports(as % of merchandise exports) of 1962 in Netherlands to that in Spain?
Ensure brevity in your answer.  1.27. What is the ratio of the Imports(as % of merchandise exports) of 1963 in Netherlands to that in Spain?
Provide a succinct answer. 0.77. What is the ratio of the Imports(as % of merchandise exports) of 1964 in Netherlands to that in Spain?
Keep it short and to the point. 0.86. What is the ratio of the Imports(as % of merchandise exports) in 1965 in Netherlands to that in Spain?
Your answer should be compact. 0.87. What is the ratio of the Imports(as % of merchandise exports) in 1962 in Paraguay to that in Philippines?
Your response must be concise. 0.59. What is the ratio of the Imports(as % of merchandise exports) in 1963 in Paraguay to that in Philippines?
Give a very brief answer. 0.69. What is the ratio of the Imports(as % of merchandise exports) of 1964 in Paraguay to that in Philippines?
Your answer should be very brief. 0.59. What is the ratio of the Imports(as % of merchandise exports) of 1965 in Paraguay to that in Philippines?
Your answer should be compact. 0.62. What is the ratio of the Imports(as % of merchandise exports) in 1962 in Paraguay to that in Portugal?
Offer a terse response. 0.33. What is the ratio of the Imports(as % of merchandise exports) of 1963 in Paraguay to that in Portugal?
Your answer should be compact. 0.48. What is the ratio of the Imports(as % of merchandise exports) in 1964 in Paraguay to that in Portugal?
Offer a terse response. 0.41. What is the ratio of the Imports(as % of merchandise exports) of 1965 in Paraguay to that in Portugal?
Provide a succinct answer. 0.41. What is the ratio of the Imports(as % of merchandise exports) in 1962 in Paraguay to that in Singapore?
Your answer should be compact. 1.35. What is the ratio of the Imports(as % of merchandise exports) in 1963 in Paraguay to that in Singapore?
Make the answer very short. 1.48. What is the ratio of the Imports(as % of merchandise exports) of 1964 in Paraguay to that in Singapore?
Your response must be concise. 1.29. What is the ratio of the Imports(as % of merchandise exports) of 1965 in Paraguay to that in Singapore?
Your answer should be compact. 1.23. What is the ratio of the Imports(as % of merchandise exports) in 1962 in Paraguay to that in Spain?
Offer a very short reply. 0.21. What is the ratio of the Imports(as % of merchandise exports) of 1963 in Paraguay to that in Spain?
Your answer should be compact. 0.32. What is the ratio of the Imports(as % of merchandise exports) in 1964 in Paraguay to that in Spain?
Make the answer very short. 0.24. What is the ratio of the Imports(as % of merchandise exports) of 1965 in Paraguay to that in Spain?
Keep it short and to the point. 0.24. What is the ratio of the Imports(as % of merchandise exports) of 1962 in Philippines to that in Portugal?
Your answer should be compact. 0.55. What is the ratio of the Imports(as % of merchandise exports) of 1963 in Philippines to that in Portugal?
Give a very brief answer. 0.69. What is the ratio of the Imports(as % of merchandise exports) of 1964 in Philippines to that in Portugal?
Provide a succinct answer. 0.7. What is the ratio of the Imports(as % of merchandise exports) of 1965 in Philippines to that in Portugal?
Offer a terse response. 0.66. What is the ratio of the Imports(as % of merchandise exports) of 1962 in Philippines to that in Singapore?
Provide a short and direct response. 2.27. What is the ratio of the Imports(as % of merchandise exports) of 1963 in Philippines to that in Singapore?
Keep it short and to the point. 2.15. What is the ratio of the Imports(as % of merchandise exports) of 1964 in Philippines to that in Singapore?
Ensure brevity in your answer.  2.18. What is the ratio of the Imports(as % of merchandise exports) in 1965 in Philippines to that in Singapore?
Give a very brief answer. 1.98. What is the ratio of the Imports(as % of merchandise exports) in 1962 in Philippines to that in Spain?
Give a very brief answer. 0.35. What is the ratio of the Imports(as % of merchandise exports) in 1963 in Philippines to that in Spain?
Keep it short and to the point. 0.47. What is the ratio of the Imports(as % of merchandise exports) in 1964 in Philippines to that in Spain?
Your answer should be compact. 0.4. What is the ratio of the Imports(as % of merchandise exports) of 1965 in Philippines to that in Spain?
Your answer should be very brief. 0.39. What is the ratio of the Imports(as % of merchandise exports) in 1962 in Portugal to that in Singapore?
Your response must be concise. 4.15. What is the ratio of the Imports(as % of merchandise exports) in 1963 in Portugal to that in Singapore?
Keep it short and to the point. 3.11. What is the ratio of the Imports(as % of merchandise exports) in 1964 in Portugal to that in Singapore?
Offer a very short reply. 3.12. What is the ratio of the Imports(as % of merchandise exports) in 1965 in Portugal to that in Singapore?
Offer a very short reply. 3. What is the ratio of the Imports(as % of merchandise exports) in 1962 in Portugal to that in Spain?
Provide a short and direct response. 0.64. What is the ratio of the Imports(as % of merchandise exports) in 1963 in Portugal to that in Spain?
Provide a short and direct response. 0.68. What is the ratio of the Imports(as % of merchandise exports) in 1964 in Portugal to that in Spain?
Provide a succinct answer. 0.58. What is the ratio of the Imports(as % of merchandise exports) in 1965 in Portugal to that in Spain?
Your response must be concise. 0.6. What is the ratio of the Imports(as % of merchandise exports) of 1962 in Singapore to that in Spain?
Offer a terse response. 0.15. What is the ratio of the Imports(as % of merchandise exports) in 1963 in Singapore to that in Spain?
Ensure brevity in your answer.  0.22. What is the ratio of the Imports(as % of merchandise exports) of 1964 in Singapore to that in Spain?
Offer a terse response. 0.19. What is the ratio of the Imports(as % of merchandise exports) of 1965 in Singapore to that in Spain?
Give a very brief answer. 0.2. What is the difference between the highest and the second highest Imports(as % of merchandise exports) in 1962?
Your response must be concise. 1.73. What is the difference between the highest and the second highest Imports(as % of merchandise exports) in 1963?
Give a very brief answer. 1.27. What is the difference between the highest and the second highest Imports(as % of merchandise exports) of 1964?
Give a very brief answer. 0.9. What is the difference between the highest and the second highest Imports(as % of merchandise exports) of 1965?
Provide a succinct answer. 0.88. What is the difference between the highest and the lowest Imports(as % of merchandise exports) of 1962?
Offer a terse response. 7.17. What is the difference between the highest and the lowest Imports(as % of merchandise exports) in 1963?
Your response must be concise. 4.29. What is the difference between the highest and the lowest Imports(as % of merchandise exports) of 1964?
Provide a short and direct response. 5.16. What is the difference between the highest and the lowest Imports(as % of merchandise exports) of 1965?
Your answer should be compact. 5.42. 